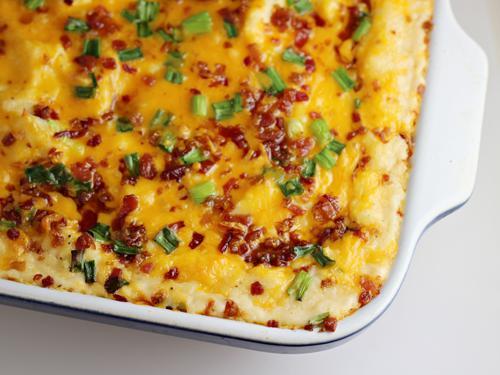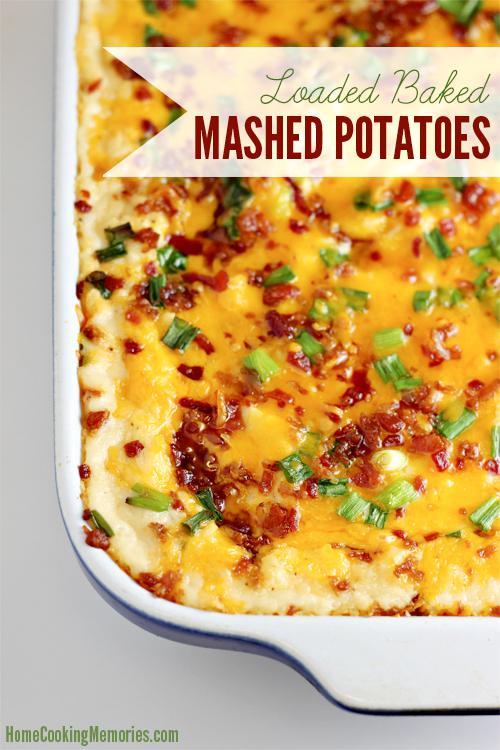The first image is the image on the left, the second image is the image on the right. Evaluate the accuracy of this statement regarding the images: "There are sppons near mashed potatoes.". Is it true? Answer yes or no. No. 